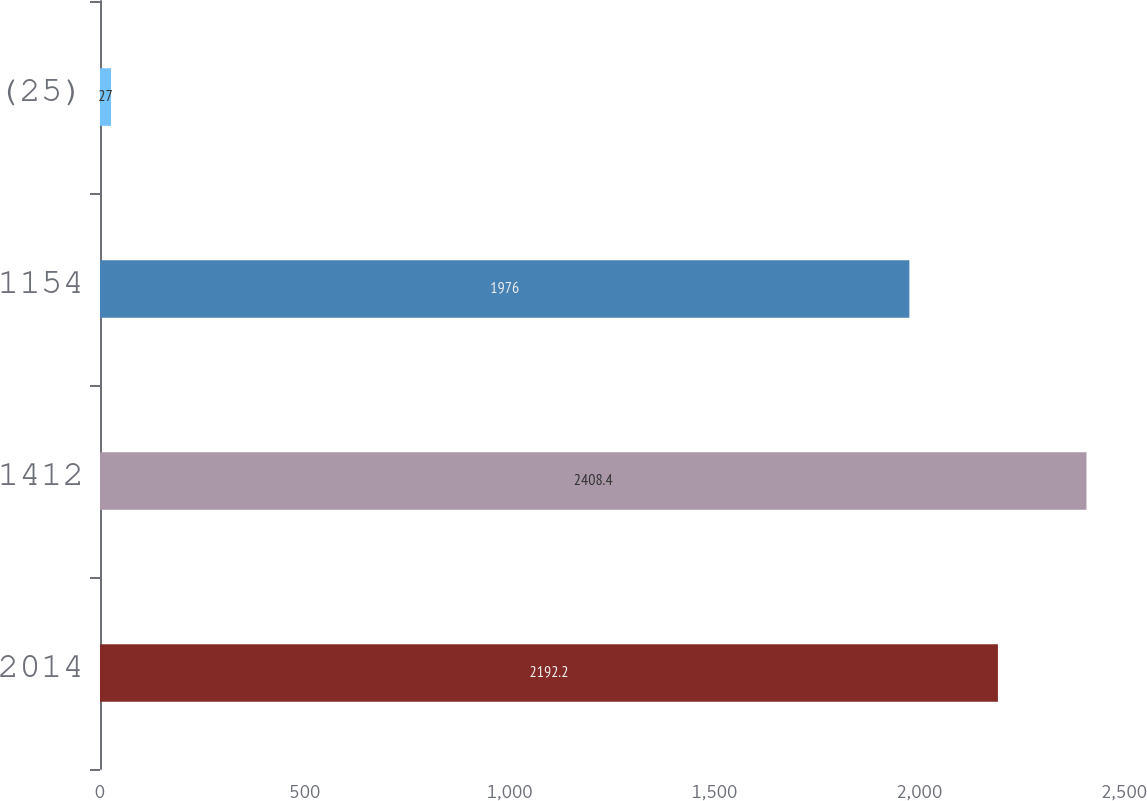Convert chart. <chart><loc_0><loc_0><loc_500><loc_500><bar_chart><fcel>2014<fcel>1412<fcel>1154<fcel>(25)<nl><fcel>2192.2<fcel>2408.4<fcel>1976<fcel>27<nl></chart> 